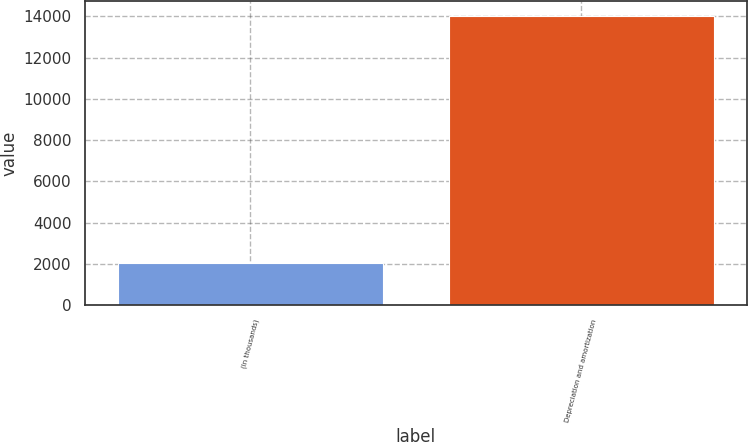Convert chart to OTSL. <chart><loc_0><loc_0><loc_500><loc_500><bar_chart><fcel>(In thousands)<fcel>Depreciation and amortization<nl><fcel>2017<fcel>14023<nl></chart> 